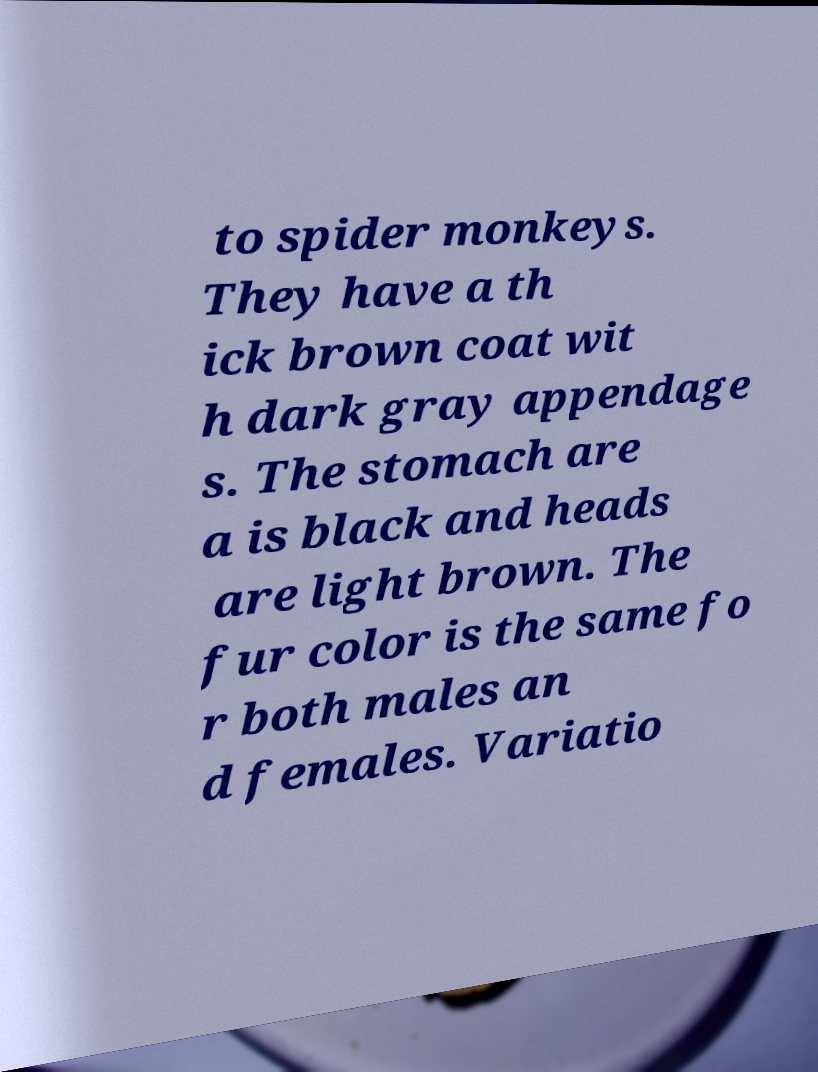Could you extract and type out the text from this image? to spider monkeys. They have a th ick brown coat wit h dark gray appendage s. The stomach are a is black and heads are light brown. The fur color is the same fo r both males an d females. Variatio 